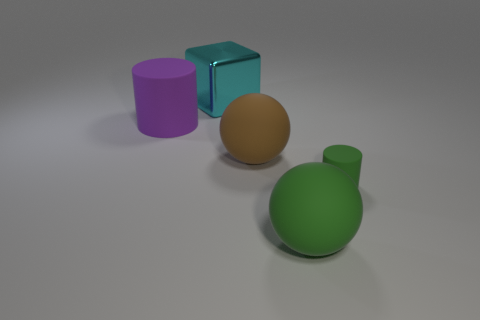Add 2 small gray matte balls. How many objects exist? 7 Subtract all balls. How many objects are left? 3 Subtract 0 red cubes. How many objects are left? 5 Subtract all large gray matte cylinders. Subtract all green rubber things. How many objects are left? 3 Add 4 purple cylinders. How many purple cylinders are left? 5 Add 2 green matte objects. How many green matte objects exist? 4 